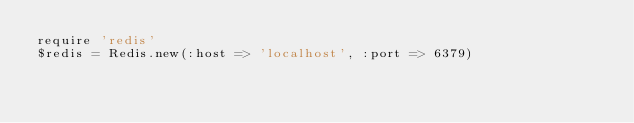Convert code to text. <code><loc_0><loc_0><loc_500><loc_500><_Ruby_>require 'redis'
$redis = Redis.new(:host => 'localhost', :port => 6379)
</code> 